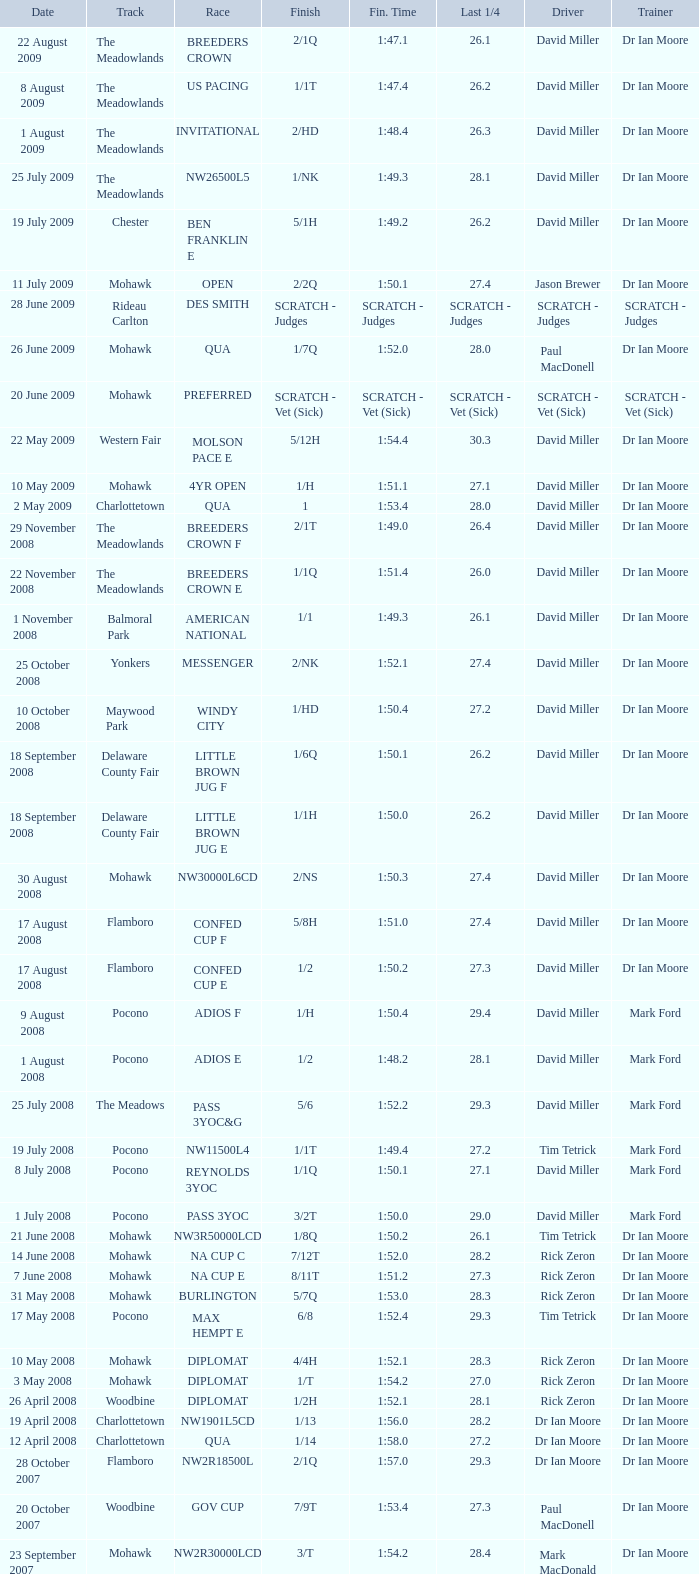1? 29.2. 